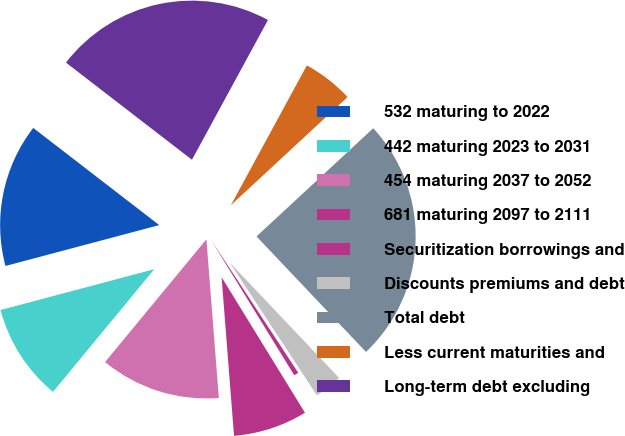Convert chart. <chart><loc_0><loc_0><loc_500><loc_500><pie_chart><fcel>532 maturing to 2022<fcel>442 maturing 2023 to 2031<fcel>454 maturing 2037 to 2052<fcel>681 maturing 2097 to 2111<fcel>Securitization borrowings and<fcel>Discounts premiums and debt<fcel>Total debt<fcel>Less current maturities and<fcel>Long-term debt excluding<nl><fcel>14.59%<fcel>9.88%<fcel>12.23%<fcel>7.53%<fcel>0.47%<fcel>2.83%<fcel>24.82%<fcel>5.18%<fcel>22.47%<nl></chart> 